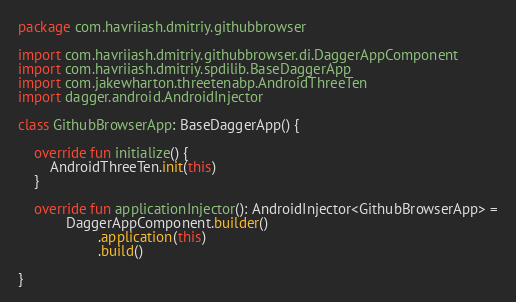<code> <loc_0><loc_0><loc_500><loc_500><_Kotlin_>package com.havriiash.dmitriy.githubbrowser

import com.havriiash.dmitriy.githubbrowser.di.DaggerAppComponent
import com.havriiash.dmitriy.spdilib.BaseDaggerApp
import com.jakewharton.threetenabp.AndroidThreeTen
import dagger.android.AndroidInjector

class GithubBrowserApp: BaseDaggerApp() {

    override fun initialize() {
        AndroidThreeTen.init(this)
    }

    override fun applicationInjector(): AndroidInjector<GithubBrowserApp> =
            DaggerAppComponent.builder()
                    .application(this)
                    .build()

}</code> 